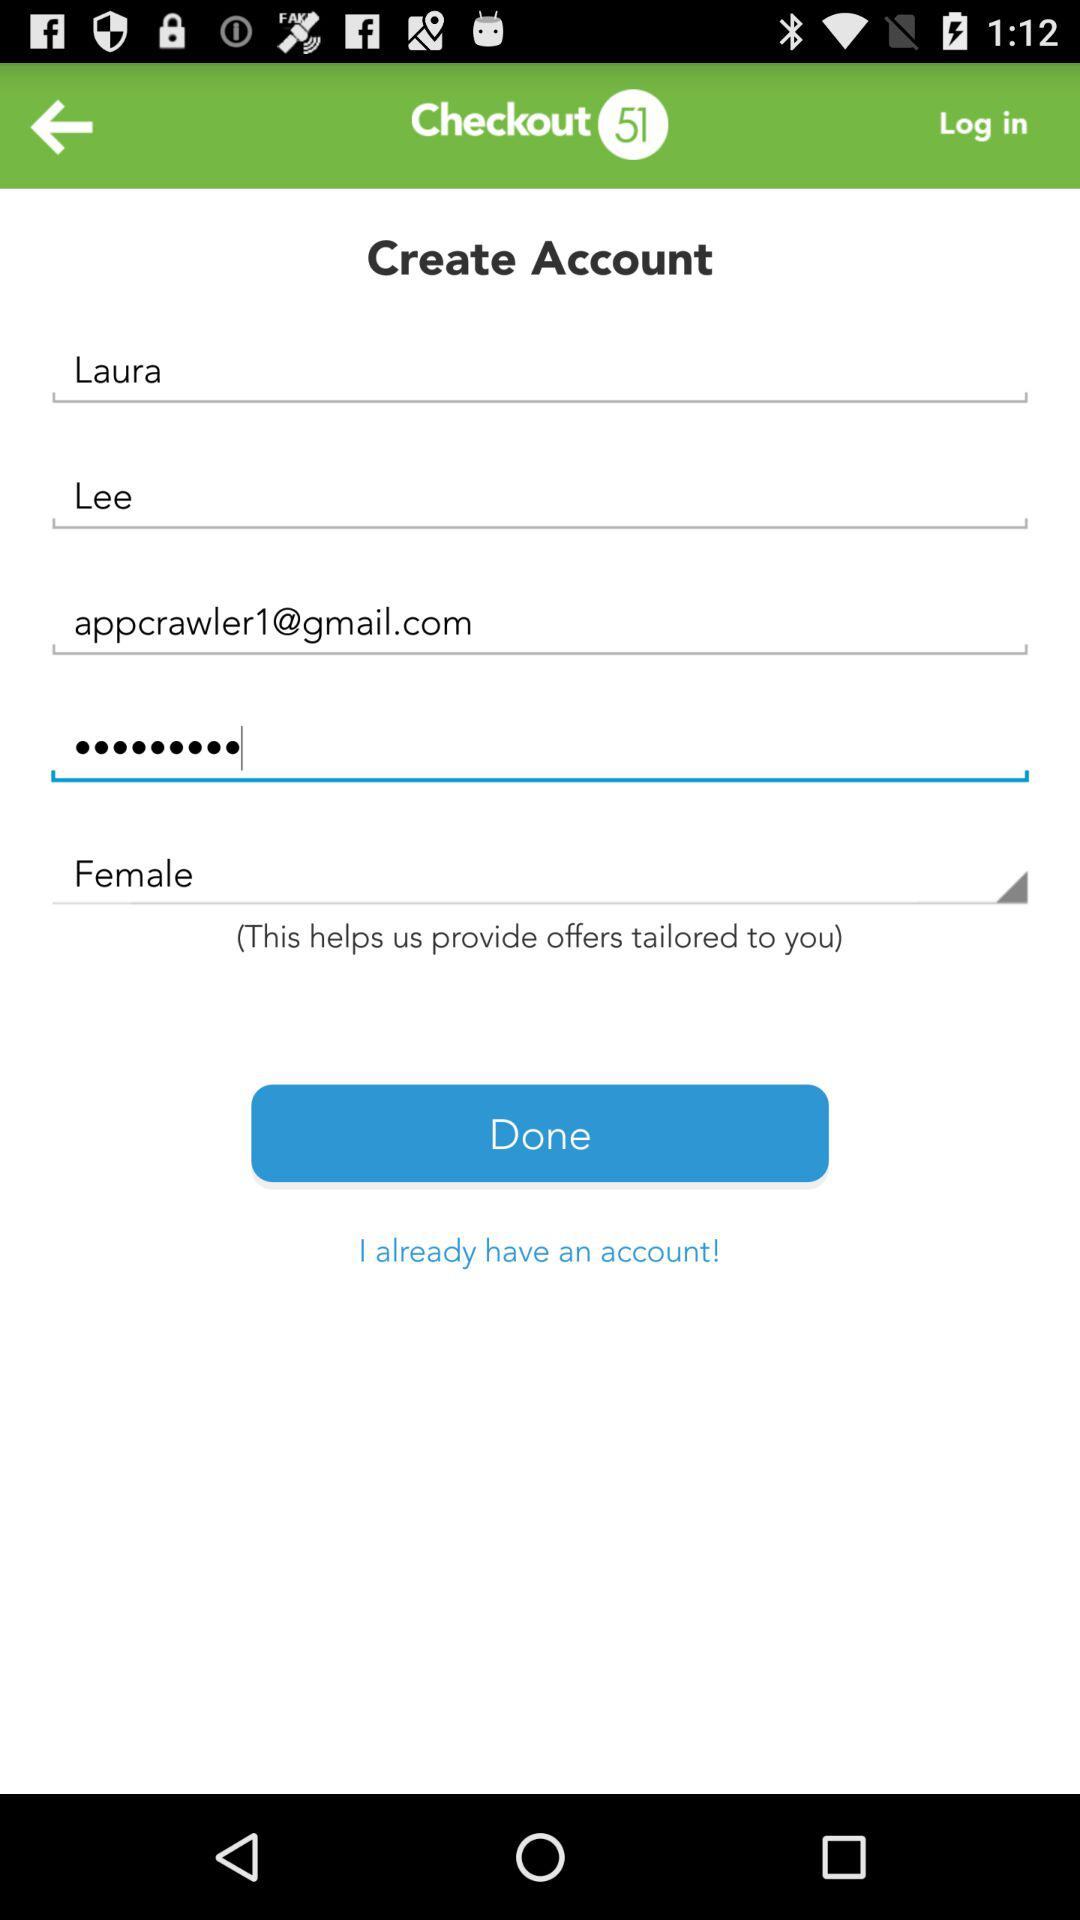What is first name? The first name is Laura. 